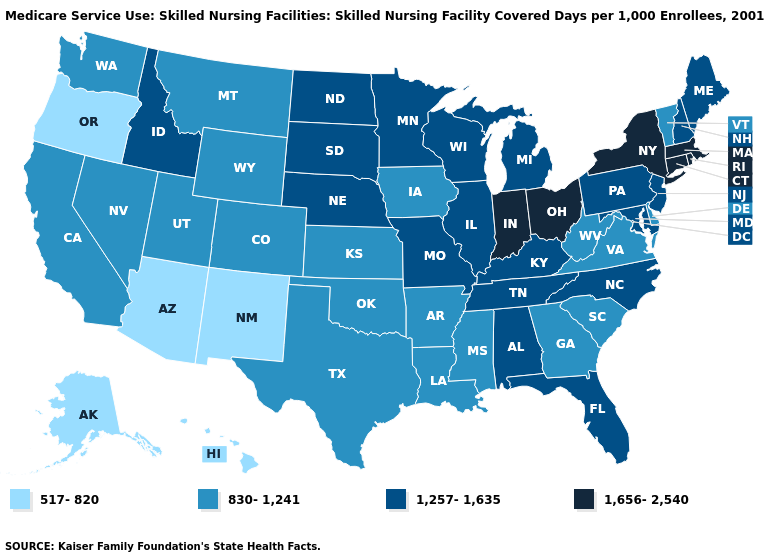Name the states that have a value in the range 830-1,241?
Keep it brief. Arkansas, California, Colorado, Delaware, Georgia, Iowa, Kansas, Louisiana, Mississippi, Montana, Nevada, Oklahoma, South Carolina, Texas, Utah, Vermont, Virginia, Washington, West Virginia, Wyoming. What is the value of New Jersey?
Keep it brief. 1,257-1,635. Name the states that have a value in the range 1,656-2,540?
Keep it brief. Connecticut, Indiana, Massachusetts, New York, Ohio, Rhode Island. Is the legend a continuous bar?
Write a very short answer. No. What is the lowest value in states that border Colorado?
Write a very short answer. 517-820. How many symbols are there in the legend?
Write a very short answer. 4. Name the states that have a value in the range 1,257-1,635?
Be succinct. Alabama, Florida, Idaho, Illinois, Kentucky, Maine, Maryland, Michigan, Minnesota, Missouri, Nebraska, New Hampshire, New Jersey, North Carolina, North Dakota, Pennsylvania, South Dakota, Tennessee, Wisconsin. Name the states that have a value in the range 1,257-1,635?
Concise answer only. Alabama, Florida, Idaho, Illinois, Kentucky, Maine, Maryland, Michigan, Minnesota, Missouri, Nebraska, New Hampshire, New Jersey, North Carolina, North Dakota, Pennsylvania, South Dakota, Tennessee, Wisconsin. Among the states that border Ohio , which have the highest value?
Concise answer only. Indiana. Name the states that have a value in the range 1,656-2,540?
Give a very brief answer. Connecticut, Indiana, Massachusetts, New York, Ohio, Rhode Island. Which states have the highest value in the USA?
Keep it brief. Connecticut, Indiana, Massachusetts, New York, Ohio, Rhode Island. What is the value of Nebraska?
Keep it brief. 1,257-1,635. Which states have the highest value in the USA?
Quick response, please. Connecticut, Indiana, Massachusetts, New York, Ohio, Rhode Island. Does Alaska have a lower value than New Mexico?
Short answer required. No. What is the highest value in the MidWest ?
Quick response, please. 1,656-2,540. 